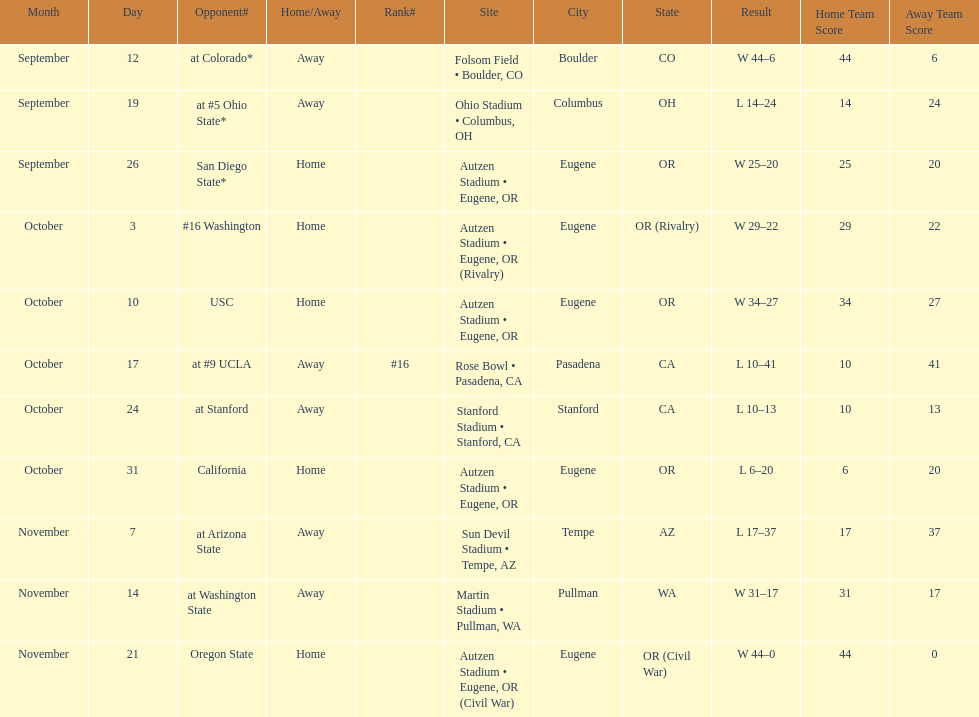Were the results of the game of november 14 above or below the results of the october 17 game? Above. 